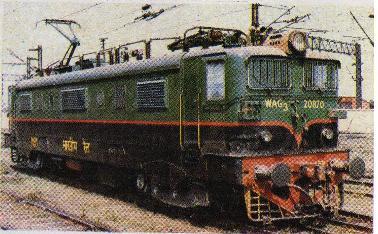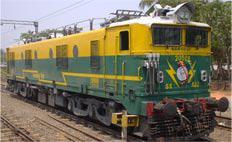The first image is the image on the left, the second image is the image on the right. For the images displayed, is the sentence "A red train with a yellowish stripe running its length is angled facing rightward." factually correct? Answer yes or no. No. The first image is the image on the left, the second image is the image on the right. Analyze the images presented: Is the assertion "There are two trains going in the same direction, none of which are red." valid? Answer yes or no. Yes. 